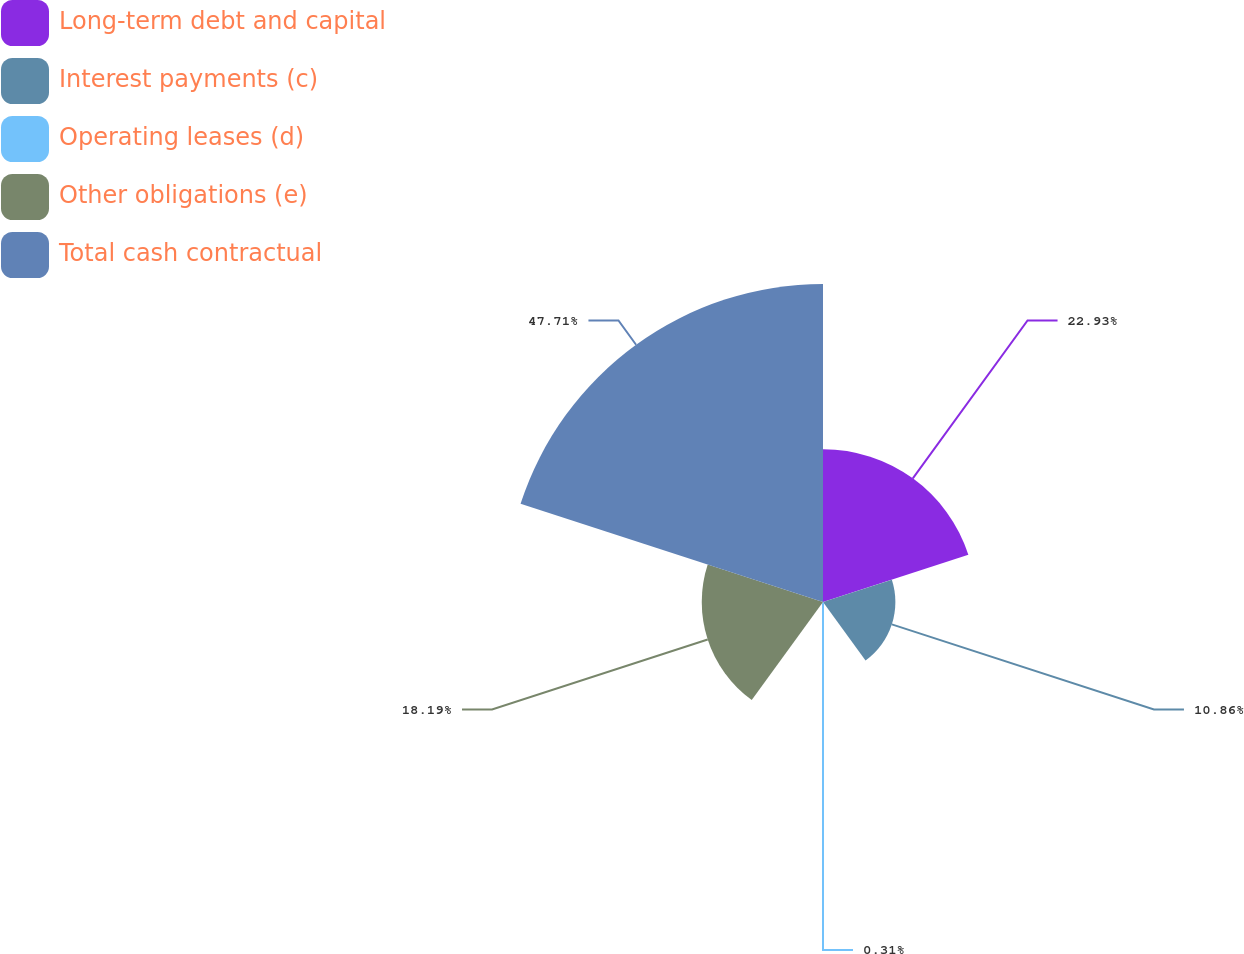<chart> <loc_0><loc_0><loc_500><loc_500><pie_chart><fcel>Long-term debt and capital<fcel>Interest payments (c)<fcel>Operating leases (d)<fcel>Other obligations (e)<fcel>Total cash contractual<nl><fcel>22.93%<fcel>10.86%<fcel>0.31%<fcel>18.19%<fcel>47.71%<nl></chart> 